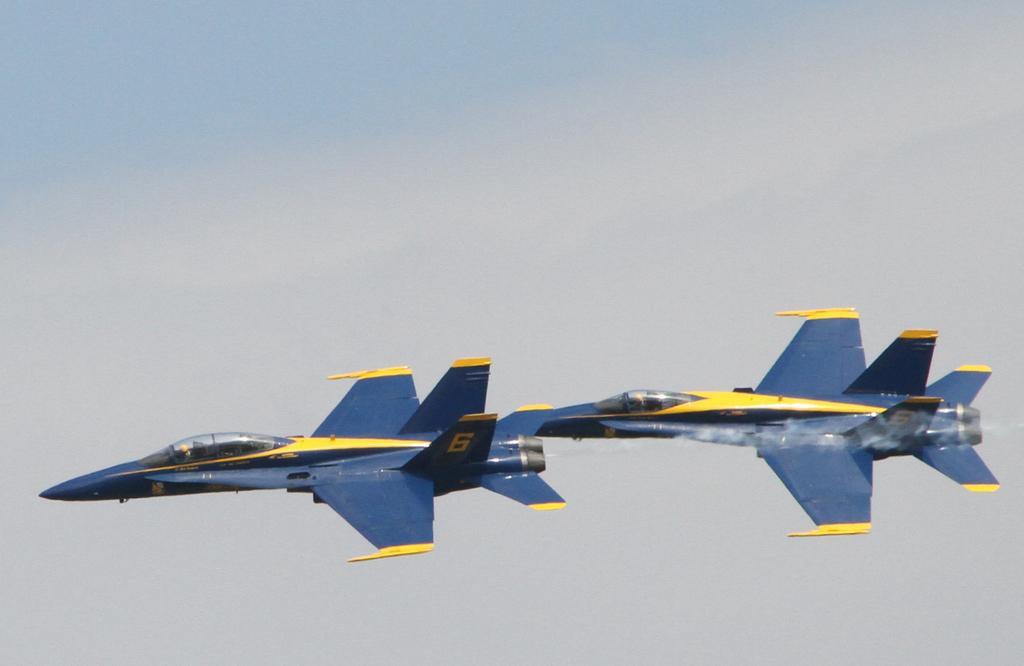<image>
Summarize the visual content of the image. blue and yellow jet plane with numbers 6 and 5 flying in the sky 